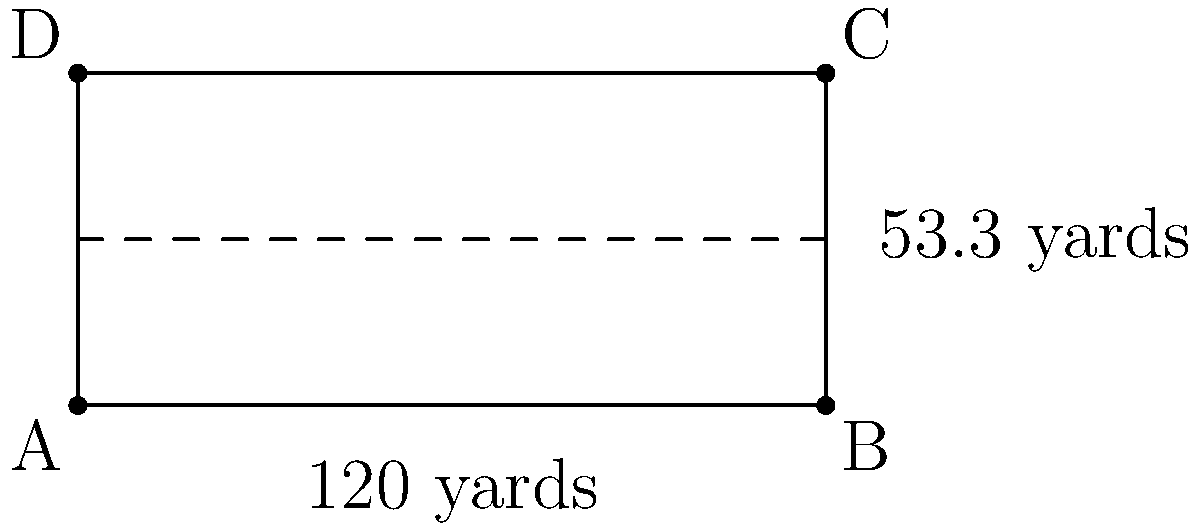As a dedicated Air Force Falcons fan, you know the dimensions of the Falcon Stadium field. The field is a rectangle measuring 120 yards in length and 53.3 yards in width. What is the total area of the Air Force Academy football field in square feet? To find the area of the Air Force Academy football field, we need to follow these steps:

1) The field is a rectangle, so we use the formula: $A = l \times w$, where $A$ is area, $l$ is length, and $w$ is width.

2) We're given the dimensions in yards, but the question asks for square feet. So we need to convert yards to feet:
   1 yard = 3 feet

3) Convert length: 120 yards $\times$ 3 = 360 feet
   Convert width: 53.3 yards $\times$ 3 = 159.9 feet

4) Now we can calculate the area:
   $A = 360 \text{ ft} \times 159.9 \text{ ft} = 57,564 \text{ sq ft}$

Therefore, the total area of the Air Force Academy football field is 57,564 square feet.
Answer: 57,564 sq ft 